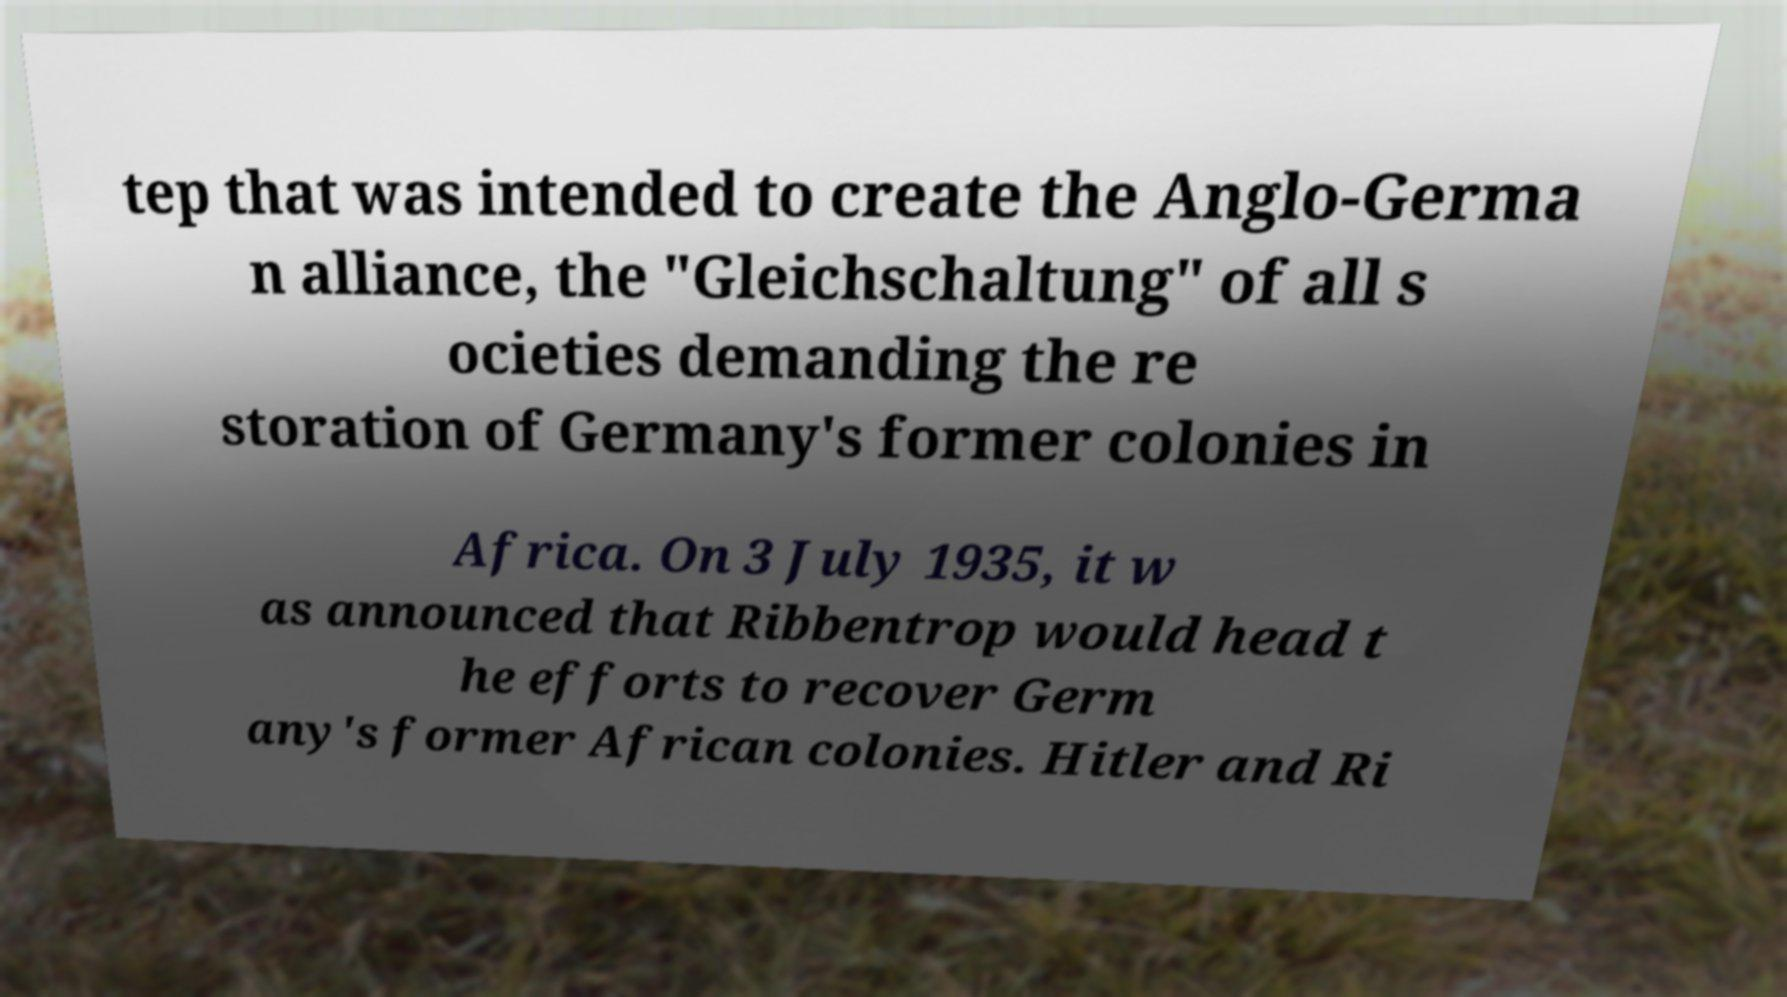Please read and relay the text visible in this image. What does it say? tep that was intended to create the Anglo-Germa n alliance, the "Gleichschaltung" of all s ocieties demanding the re storation of Germany's former colonies in Africa. On 3 July 1935, it w as announced that Ribbentrop would head t he efforts to recover Germ any's former African colonies. Hitler and Ri 